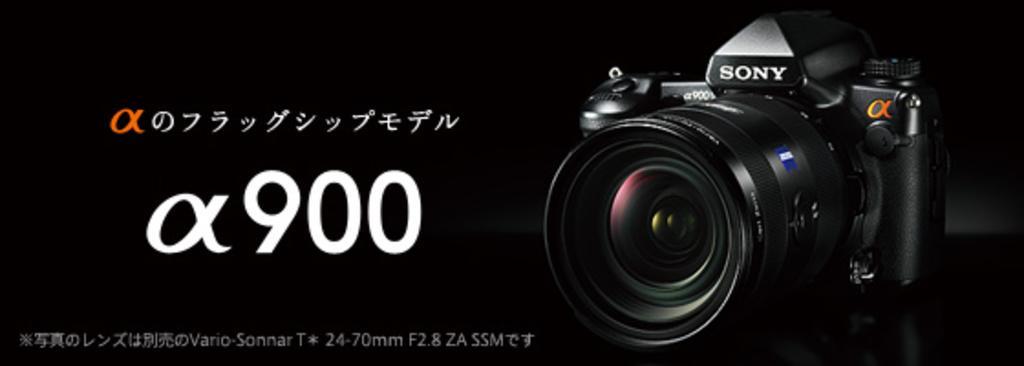Please provide a concise description of this image. The picture consists of a camera. on the left there is text and numbers. The background is dark. 